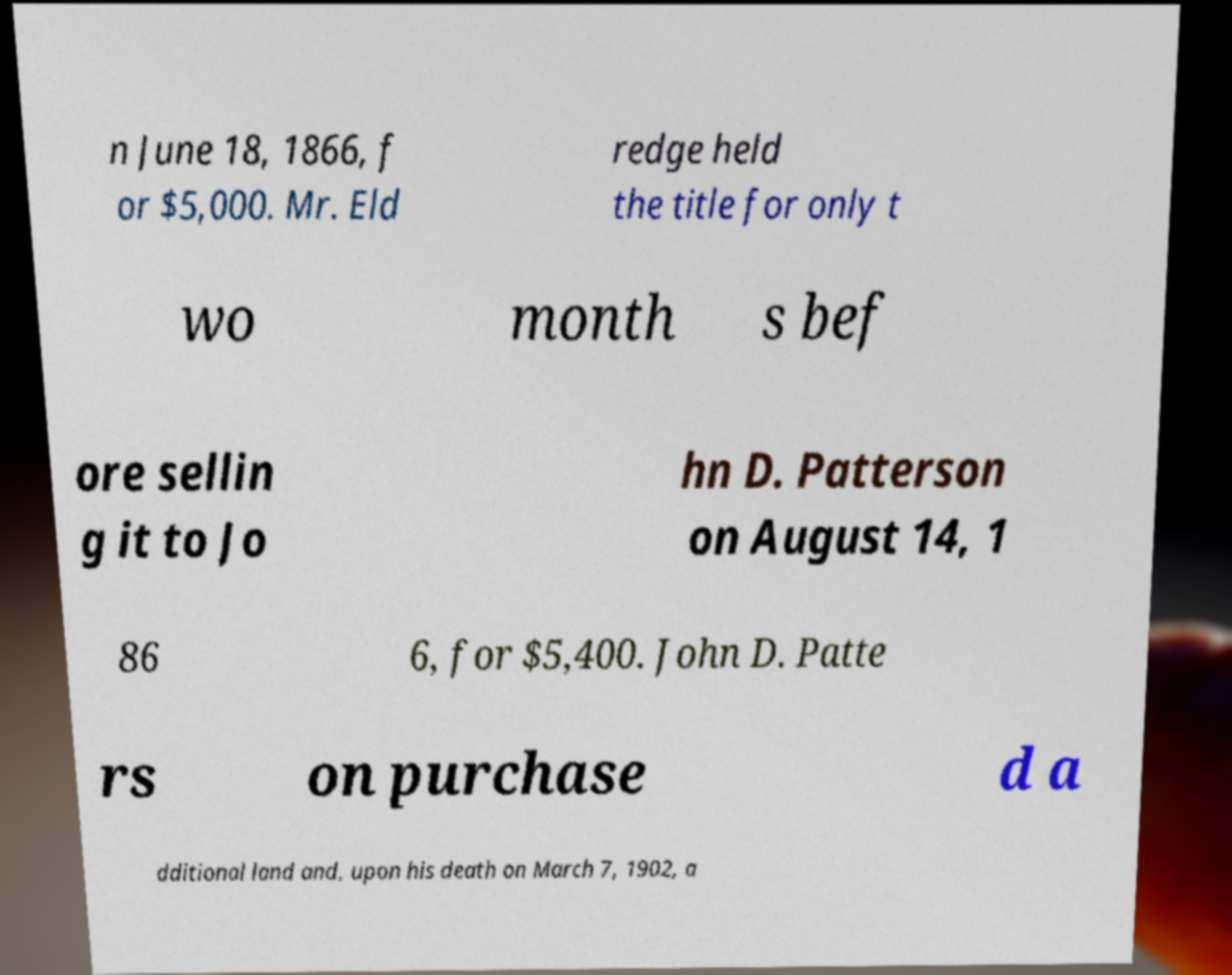I need the written content from this picture converted into text. Can you do that? n June 18, 1866, f or $5,000. Mr. Eld redge held the title for only t wo month s bef ore sellin g it to Jo hn D. Patterson on August 14, 1 86 6, for $5,400. John D. Patte rs on purchase d a dditional land and, upon his death on March 7, 1902, a 